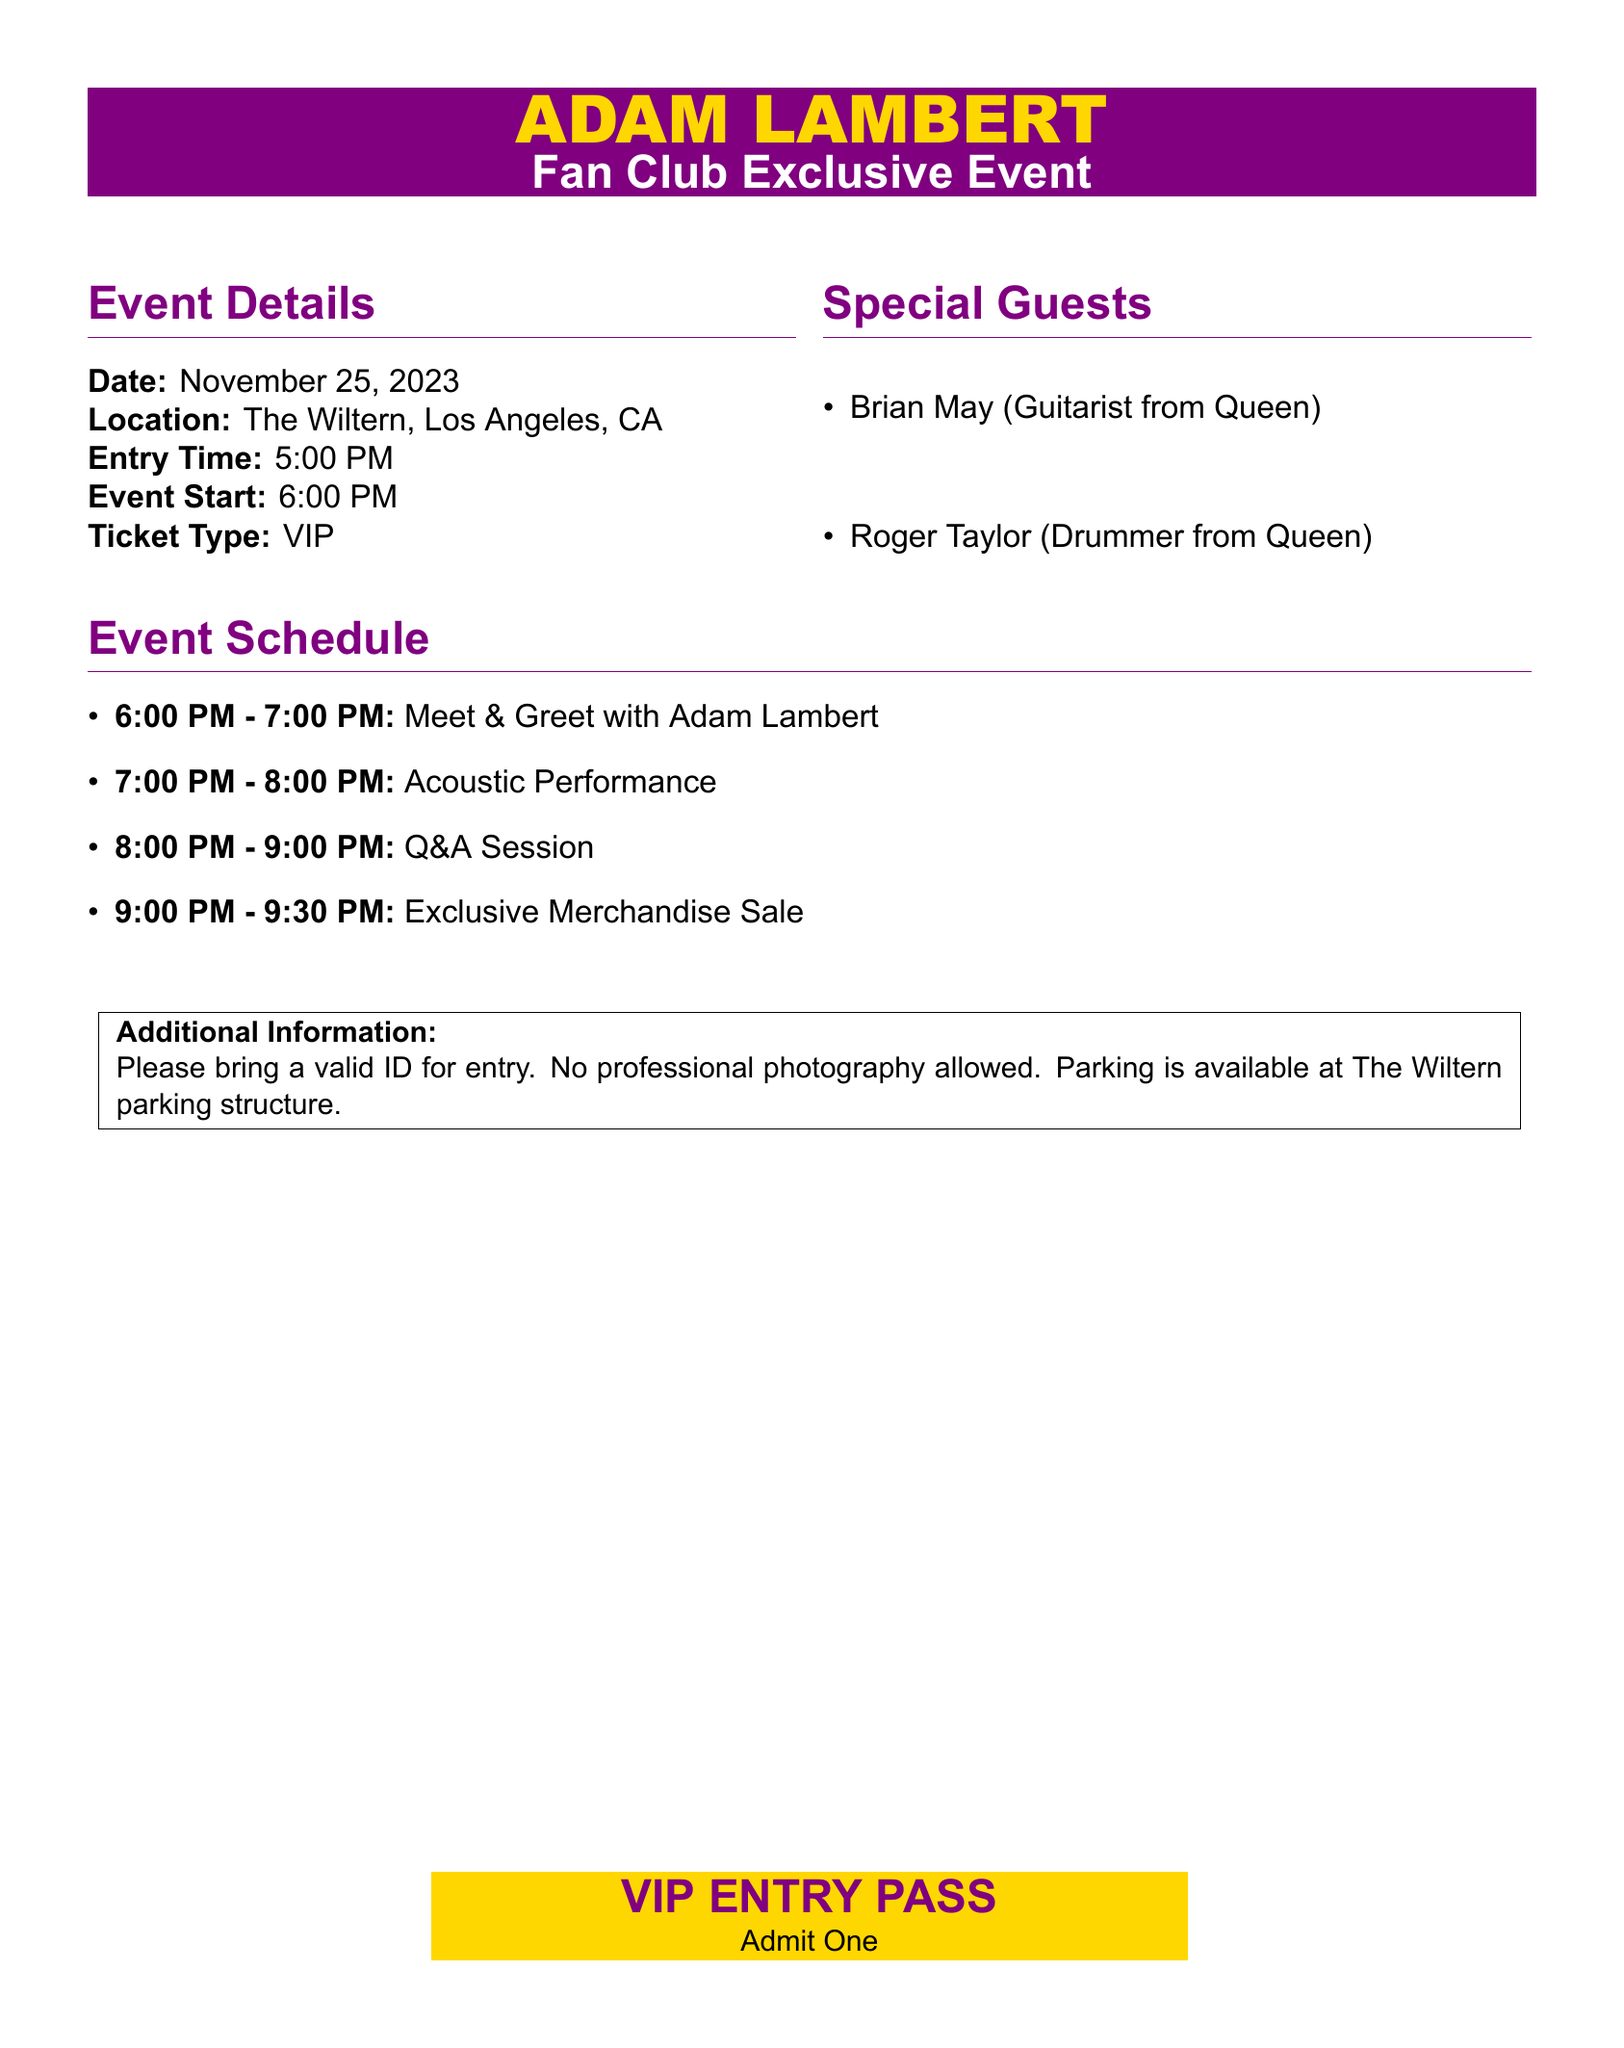what is the date of the event? The date of the event is specified clearly in the document under Event Details.
Answer: November 25, 2023 where is the event taking place? The location is listed in the Event Details section of the document.
Answer: The Wiltern, Los Angeles, CA what time does the event start? The starting time of the event is noted in the Event Details section.
Answer: 6:00 PM who is a special guest at this event? The special guests are mentioned in the Special Guests section of the document.
Answer: Brian May how long is the Meet & Greet with Adam Lambert? The duration of the Meet & Greet is included in the Event Schedule section of the document.
Answer: 1 hour what is the first scheduled activity of the event? The first activity is indicated in the Event Schedule section.
Answer: Meet & Greet with Adam Lambert what type of ticket is required for this event? The ticket type is specified in the Event Details section of the document.
Answer: VIP is professional photography allowed? This policy is included in the Additional Information section.
Answer: No how long does the Exclusive Merchandise Sale last? The duration of the sale is detailed in the Event Schedule section.
Answer: 30 minutes 